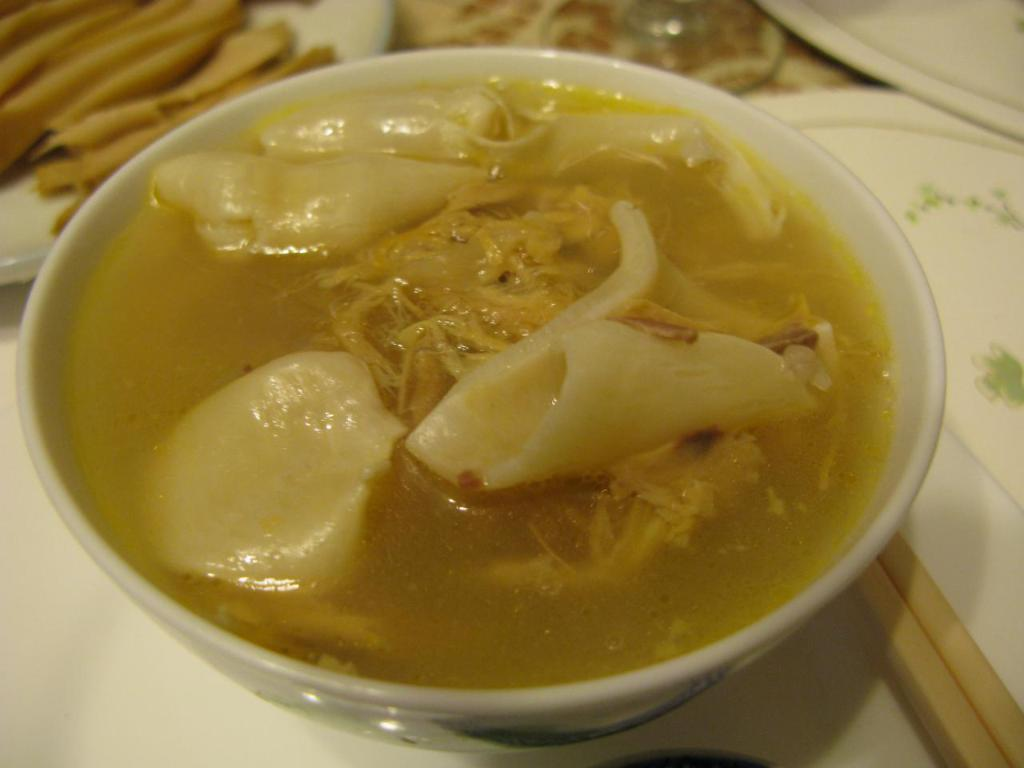What type of container is holding food in the image? There is food in a bowl in the image. What other type of container is holding food in the image? There is food on a plate in the image. Where is the bowl placed in the image? A bowl is placed on a surface in the image. How many snakes are slithering on the plate in the image? There are no snakes present in the image; it only features food on a plate and in a bowl. 